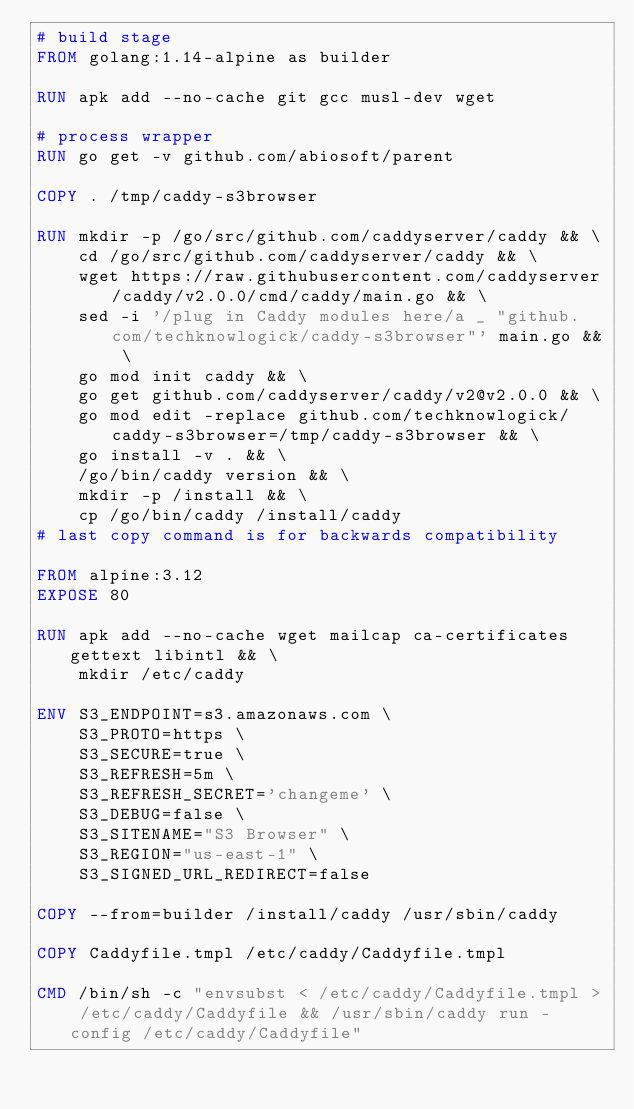<code> <loc_0><loc_0><loc_500><loc_500><_Dockerfile_># build stage
FROM golang:1.14-alpine as builder

RUN apk add --no-cache git gcc musl-dev wget

# process wrapper
RUN go get -v github.com/abiosoft/parent

COPY . /tmp/caddy-s3browser

RUN mkdir -p /go/src/github.com/caddyserver/caddy && \
    cd /go/src/github.com/caddyserver/caddy && \
    wget https://raw.githubusercontent.com/caddyserver/caddy/v2.0.0/cmd/caddy/main.go && \
    sed -i '/plug in Caddy modules here/a _ "github.com/techknowlogick/caddy-s3browser"' main.go && \
    go mod init caddy && \
    go get github.com/caddyserver/caddy/v2@v2.0.0 && \
    go mod edit -replace github.com/techknowlogick/caddy-s3browser=/tmp/caddy-s3browser && \
    go install -v . && \
    /go/bin/caddy version && \
    mkdir -p /install && \
    cp /go/bin/caddy /install/caddy
# last copy command is for backwards compatibility

FROM alpine:3.12
EXPOSE 80

RUN apk add --no-cache wget mailcap ca-certificates gettext libintl && \
    mkdir /etc/caddy

ENV S3_ENDPOINT=s3.amazonaws.com \
    S3_PROTO=https \
    S3_SECURE=true \
    S3_REFRESH=5m \
    S3_REFRESH_SECRET='changeme' \
    S3_DEBUG=false \
    S3_SITENAME="S3 Browser" \
    S3_REGION="us-east-1" \
    S3_SIGNED_URL_REDIRECT=false

COPY --from=builder /install/caddy /usr/sbin/caddy

COPY Caddyfile.tmpl /etc/caddy/Caddyfile.tmpl

CMD /bin/sh -c "envsubst < /etc/caddy/Caddyfile.tmpl > /etc/caddy/Caddyfile && /usr/sbin/caddy run -config /etc/caddy/Caddyfile"
</code> 